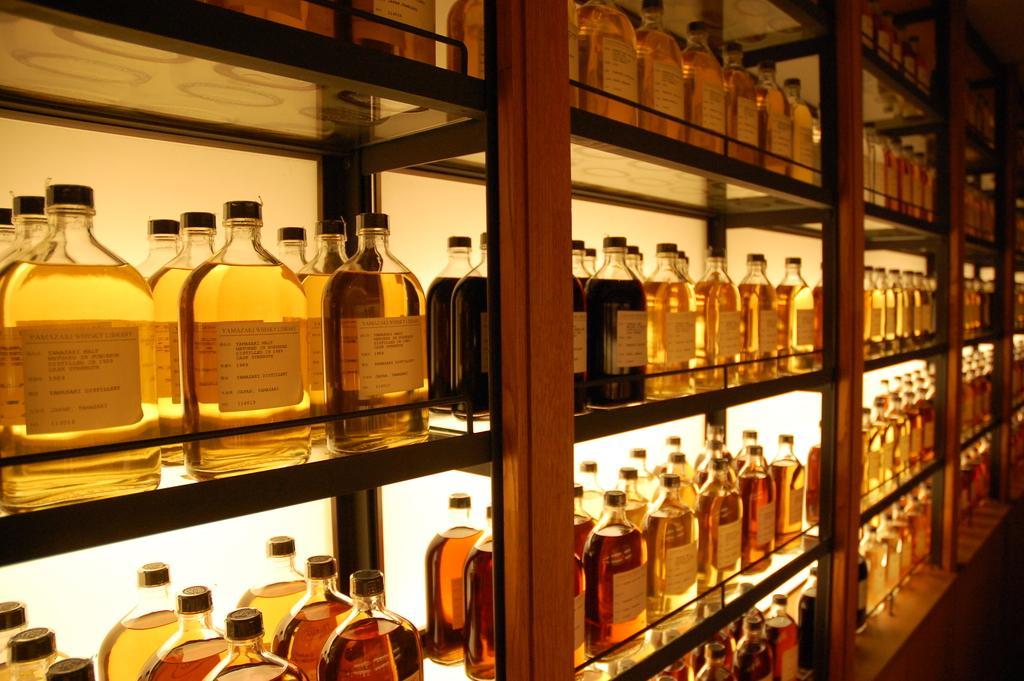Please provide a concise description of this image. In the picture there are shelves made up of glass and wood in that shelfs there are number of bottles with some drinks in it. 